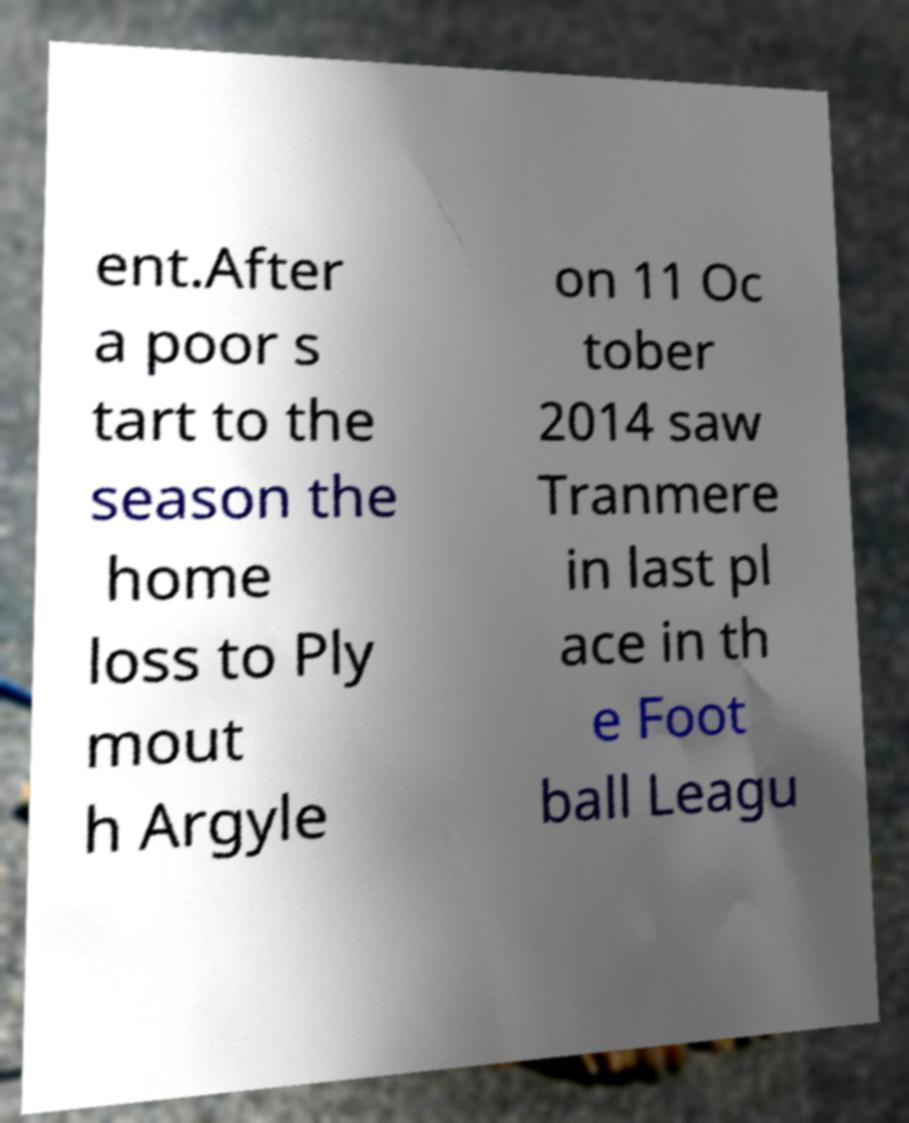Please read and relay the text visible in this image. What does it say? ent.After a poor s tart to the season the home loss to Ply mout h Argyle on 11 Oc tober 2014 saw Tranmere in last pl ace in th e Foot ball Leagu 